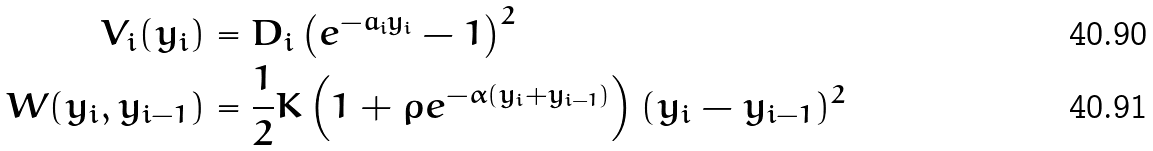<formula> <loc_0><loc_0><loc_500><loc_500>V _ { i } ( y _ { i } ) & = D _ { i } \left ( e ^ { - a _ { i } y _ { i } } - 1 \right ) ^ { 2 } \\ W ( y _ { i } , y _ { i - 1 } ) & = \frac { 1 } { 2 } K \left ( 1 + \rho e ^ { - \alpha ( y _ { i } + y _ { i - 1 } ) } \right ) ( y _ { i } - y _ { i - 1 } ) ^ { 2 }</formula> 